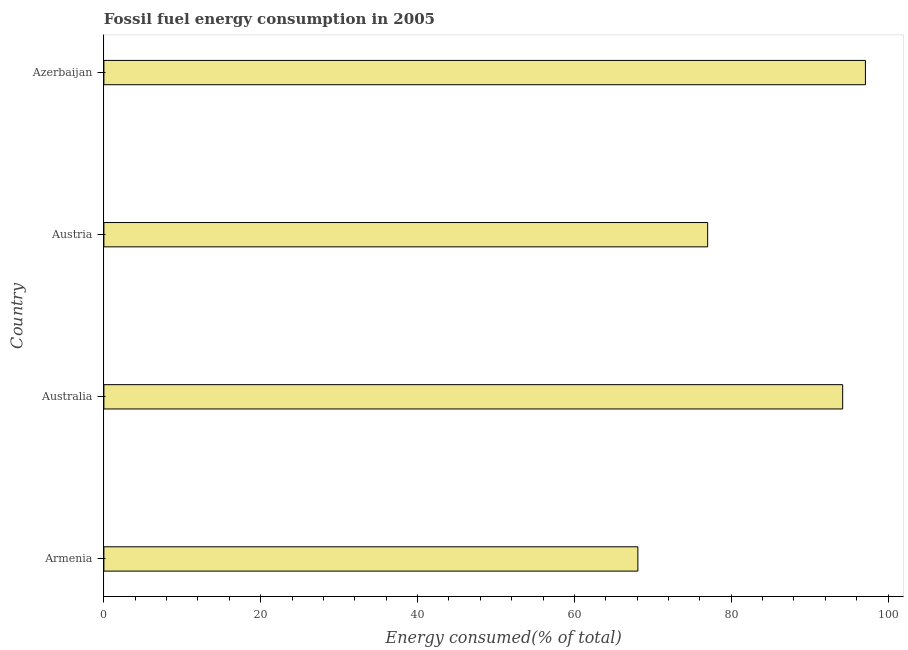What is the title of the graph?
Ensure brevity in your answer.  Fossil fuel energy consumption in 2005. What is the label or title of the X-axis?
Provide a succinct answer. Energy consumed(% of total). What is the label or title of the Y-axis?
Your answer should be compact. Country. What is the fossil fuel energy consumption in Austria?
Keep it short and to the point. 77. Across all countries, what is the maximum fossil fuel energy consumption?
Ensure brevity in your answer.  97.12. Across all countries, what is the minimum fossil fuel energy consumption?
Your answer should be compact. 68.1. In which country was the fossil fuel energy consumption maximum?
Your response must be concise. Azerbaijan. In which country was the fossil fuel energy consumption minimum?
Your answer should be very brief. Armenia. What is the sum of the fossil fuel energy consumption?
Ensure brevity in your answer.  336.43. What is the difference between the fossil fuel energy consumption in Austria and Azerbaijan?
Provide a succinct answer. -20.12. What is the average fossil fuel energy consumption per country?
Give a very brief answer. 84.11. What is the median fossil fuel energy consumption?
Keep it short and to the point. 85.61. In how many countries, is the fossil fuel energy consumption greater than 92 %?
Provide a short and direct response. 2. What is the ratio of the fossil fuel energy consumption in Armenia to that in Austria?
Offer a terse response. 0.88. Is the difference between the fossil fuel energy consumption in Armenia and Austria greater than the difference between any two countries?
Your response must be concise. No. What is the difference between the highest and the second highest fossil fuel energy consumption?
Your response must be concise. 2.9. What is the difference between the highest and the lowest fossil fuel energy consumption?
Offer a terse response. 29.02. In how many countries, is the fossil fuel energy consumption greater than the average fossil fuel energy consumption taken over all countries?
Ensure brevity in your answer.  2. How many countries are there in the graph?
Your answer should be compact. 4. Are the values on the major ticks of X-axis written in scientific E-notation?
Make the answer very short. No. What is the Energy consumed(% of total) in Armenia?
Offer a terse response. 68.1. What is the Energy consumed(% of total) in Australia?
Give a very brief answer. 94.22. What is the Energy consumed(% of total) of Austria?
Provide a succinct answer. 77. What is the Energy consumed(% of total) of Azerbaijan?
Keep it short and to the point. 97.12. What is the difference between the Energy consumed(% of total) in Armenia and Australia?
Offer a terse response. -26.12. What is the difference between the Energy consumed(% of total) in Armenia and Austria?
Offer a very short reply. -8.9. What is the difference between the Energy consumed(% of total) in Armenia and Azerbaijan?
Provide a succinct answer. -29.02. What is the difference between the Energy consumed(% of total) in Australia and Austria?
Provide a short and direct response. 17.22. What is the difference between the Energy consumed(% of total) in Australia and Azerbaijan?
Provide a short and direct response. -2.9. What is the difference between the Energy consumed(% of total) in Austria and Azerbaijan?
Ensure brevity in your answer.  -20.12. What is the ratio of the Energy consumed(% of total) in Armenia to that in Australia?
Offer a very short reply. 0.72. What is the ratio of the Energy consumed(% of total) in Armenia to that in Austria?
Keep it short and to the point. 0.88. What is the ratio of the Energy consumed(% of total) in Armenia to that in Azerbaijan?
Keep it short and to the point. 0.7. What is the ratio of the Energy consumed(% of total) in Australia to that in Austria?
Your answer should be compact. 1.22. What is the ratio of the Energy consumed(% of total) in Austria to that in Azerbaijan?
Your answer should be compact. 0.79. 